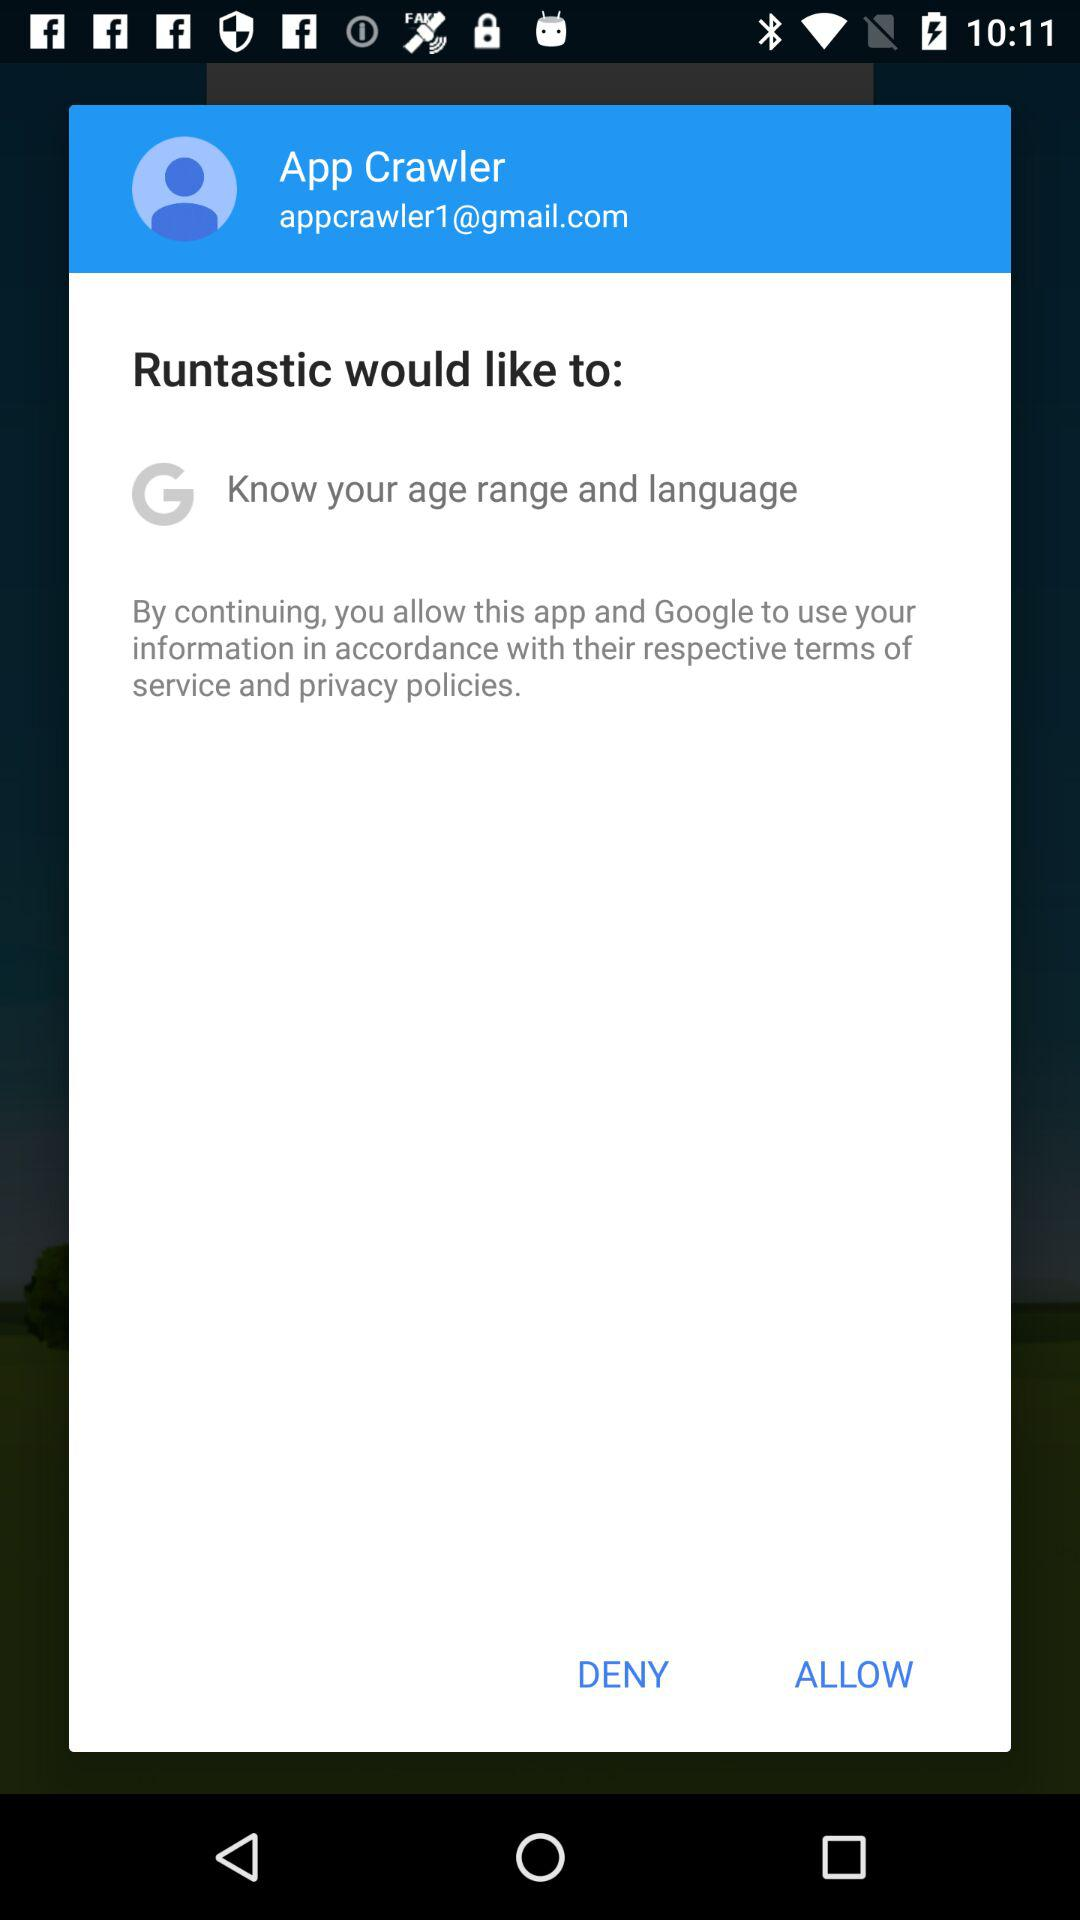What is the email address? The email address is appcrawler1@gmail.com. 